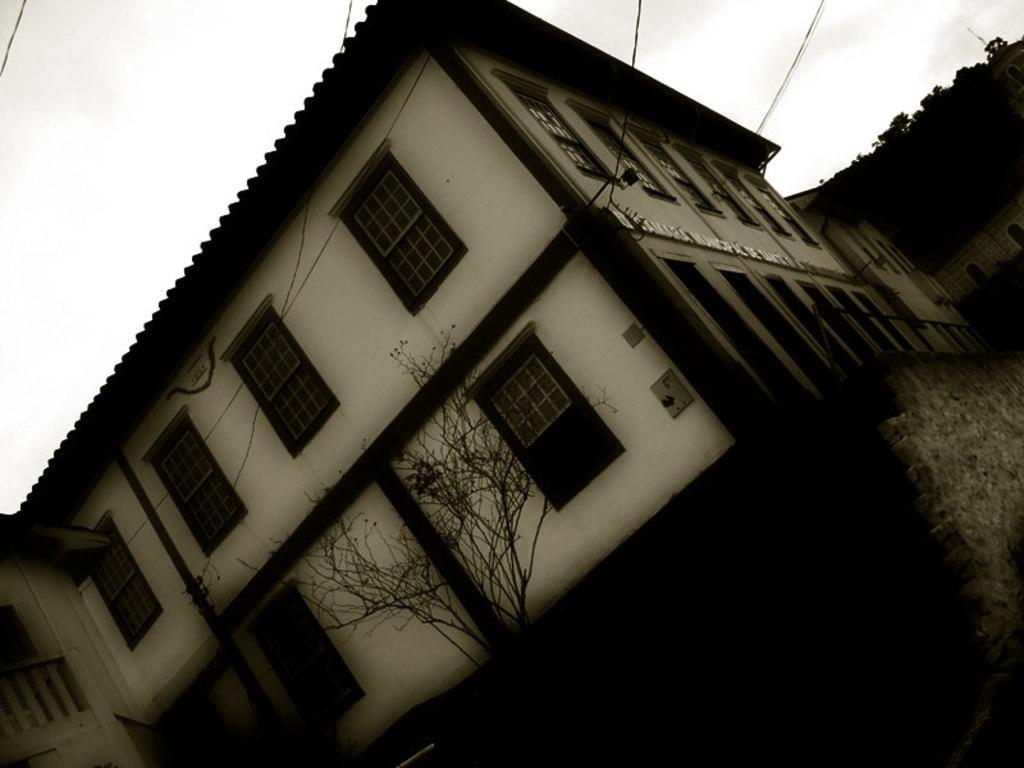Please provide a concise description of this image. In this picture we can see the sky, building, transmission wires, windows and tree. Right side portion of the picture is completely dark. 